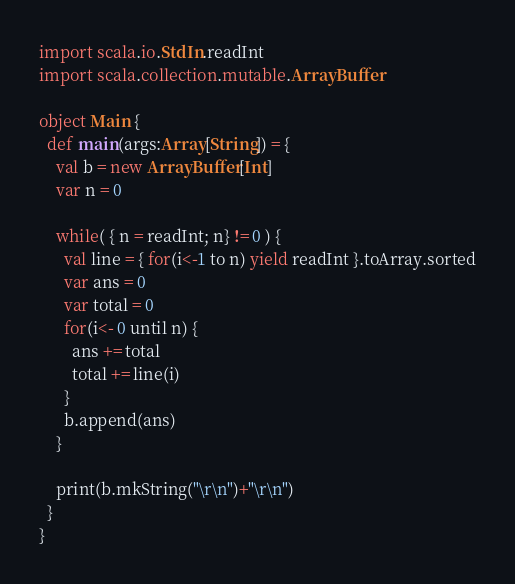<code> <loc_0><loc_0><loc_500><loc_500><_Scala_>import scala.io.StdIn.readInt
import scala.collection.mutable.ArrayBuffer

object Main {
  def main(args:Array[String]) = {
    val b = new ArrayBuffer[Int]
    var n = 0

    while( { n = readInt; n} != 0 ) {
      val line = { for(i<-1 to n) yield readInt }.toArray.sorted
      var ans = 0
      var total = 0
      for(i<- 0 until n) {
        ans += total
        total += line(i)
      }
      b.append(ans)
    }

    print(b.mkString("\r\n")+"\r\n")
  }
}</code> 